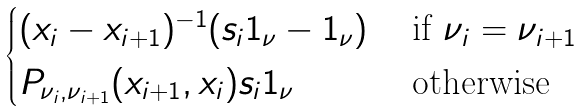<formula> <loc_0><loc_0><loc_500><loc_500>\begin{cases} ( x _ { i } - x _ { i + 1 } ) ^ { - 1 } ( s _ { i } 1 _ { \nu } - 1 _ { \nu } ) & \text { if } \nu _ { i } = \nu _ { i + 1 } \\ P _ { \nu _ { i } , \nu _ { i + 1 } } ( x _ { i + 1 } , x _ { i } ) s _ { i } 1 _ { \nu } & \text { otherwise} \end{cases}</formula> 